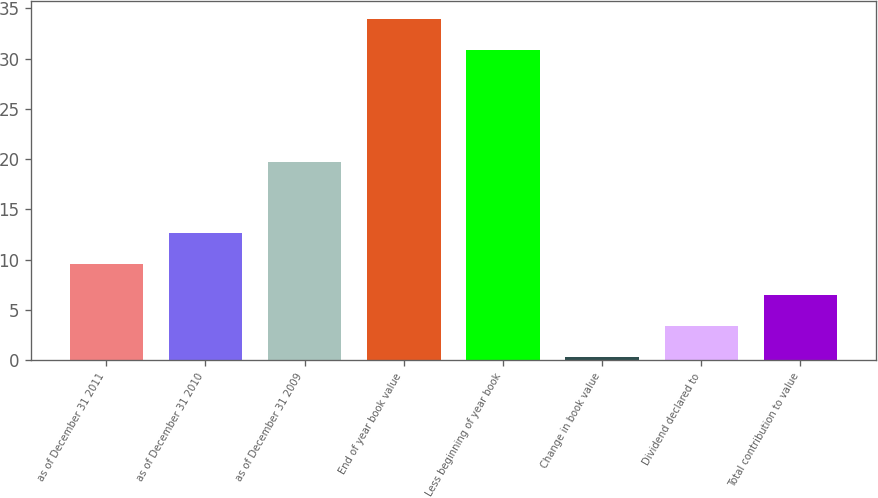Convert chart to OTSL. <chart><loc_0><loc_0><loc_500><loc_500><bar_chart><fcel>as of December 31 2011<fcel>as of December 31 2010<fcel>as of December 31 2009<fcel>End of year book value<fcel>Less beginning of year book<fcel>Change in book value<fcel>Dividend declared to<fcel>Total contribution to value<nl><fcel>9.52<fcel>12.61<fcel>19.7<fcel>34<fcel>30.91<fcel>0.25<fcel>3.34<fcel>6.43<nl></chart> 